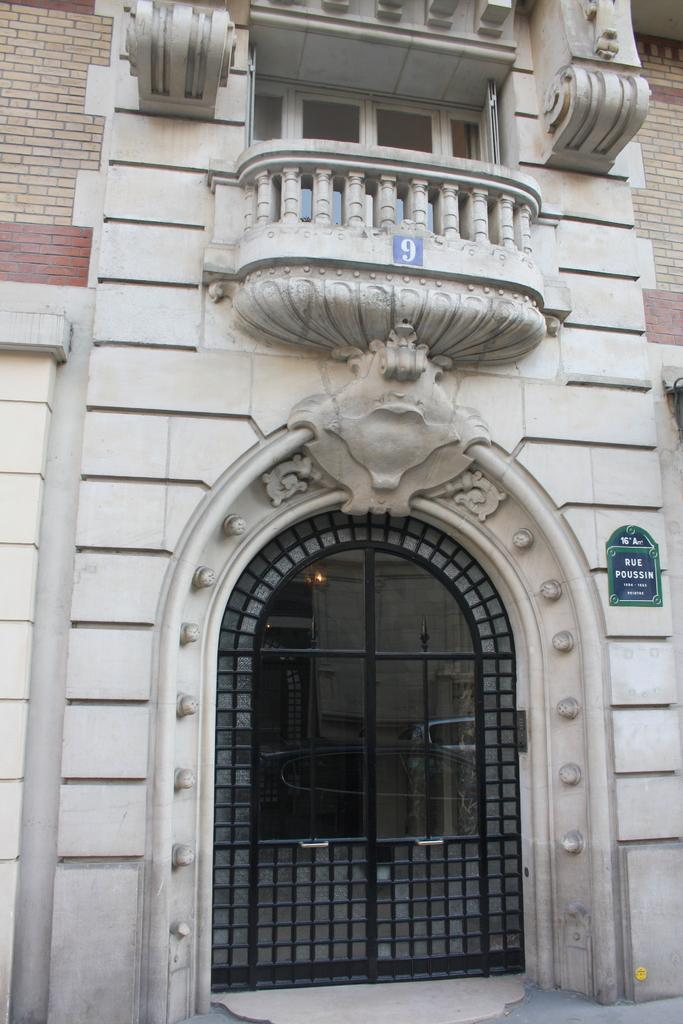What type of structure is depicted in the image? The image is of a building. Can you describe any specific features of the building? The building has brick walls and a door. Are there any openings in the building for light or ventilation? Yes, there are windows in the building. What else can be seen on the wall of the building? There is a board on the wall of the building. What type of food is being served at the harbor near the building in the image? There is no harbor or food present in the image; it only features a building with brick walls, a door, windows, and a board on the wall. 